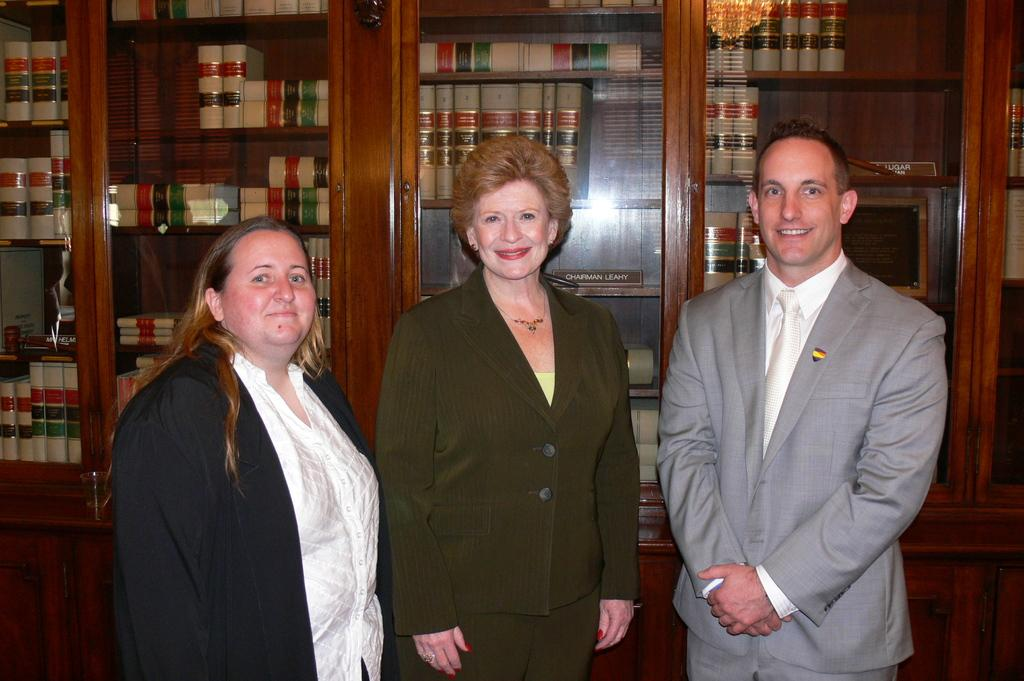How many people are in the foreground of the image? There are three people in the foreground of the image. Can you describe the positions of the people in the image? A woman is standing on the left side, a person is standing in the middle, and a man is standing on the right side. What type of music is being played by the neck of the person in the middle? There is no music or neck visible in the image; it only shows three people standing in their respective positions. 